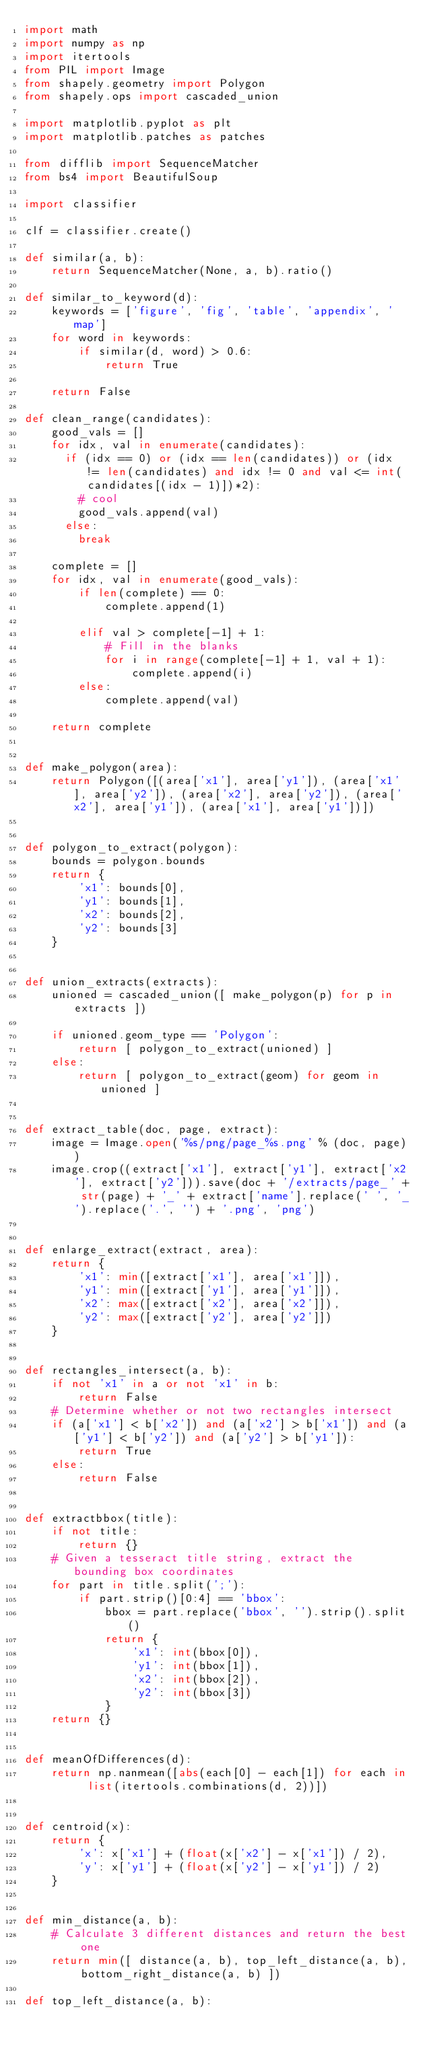<code> <loc_0><loc_0><loc_500><loc_500><_Python_>import math
import numpy as np
import itertools
from PIL import Image
from shapely.geometry import Polygon
from shapely.ops import cascaded_union

import matplotlib.pyplot as plt
import matplotlib.patches as patches

from difflib import SequenceMatcher
from bs4 import BeautifulSoup

import classifier

clf = classifier.create()

def similar(a, b):
    return SequenceMatcher(None, a, b).ratio()

def similar_to_keyword(d):
    keywords = ['figure', 'fig', 'table', 'appendix', 'map']
    for word in keywords:
        if similar(d, word) > 0.6:
            return True

    return False

def clean_range(candidates):
    good_vals = []
    for idx, val in enumerate(candidates):
      if (idx == 0) or (idx == len(candidates)) or (idx != len(candidates) and idx != 0 and val <= int(candidates[(idx - 1)])*2):
        # cool
        good_vals.append(val)
      else:
        break

    complete = []
    for idx, val in enumerate(good_vals):
        if len(complete) == 0:
            complete.append(1)

        elif val > complete[-1] + 1:
            # Fill in the blanks
            for i in range(complete[-1] + 1, val + 1):
                complete.append(i)
        else:
            complete.append(val)

    return complete


def make_polygon(area):
    return Polygon([(area['x1'], area['y1']), (area['x1'], area['y2']), (area['x2'], area['y2']), (area['x2'], area['y1']), (area['x1'], area['y1'])])


def polygon_to_extract(polygon):
    bounds = polygon.bounds
    return {
        'x1': bounds[0],
        'y1': bounds[1],
        'x2': bounds[2],
        'y2': bounds[3]
    }


def union_extracts(extracts):
    unioned = cascaded_union([ make_polygon(p) for p in extracts ])

    if unioned.geom_type == 'Polygon':
        return [ polygon_to_extract(unioned) ]
    else:
        return [ polygon_to_extract(geom) for geom in unioned ]


def extract_table(doc, page, extract):
    image = Image.open('%s/png/page_%s.png' % (doc, page))
    image.crop((extract['x1'], extract['y1'], extract['x2'], extract['y2'])).save(doc + '/extracts/page_' + str(page) + '_' + extract['name'].replace(' ', '_').replace('.', '') + '.png', 'png')


def enlarge_extract(extract, area):
    return {
        'x1': min([extract['x1'], area['x1']]),
        'y1': min([extract['y1'], area['y1']]),
        'x2': max([extract['x2'], area['x2']]),
        'y2': max([extract['y2'], area['y2']])
    }


def rectangles_intersect(a, b):
    if not 'x1' in a or not 'x1' in b:
        return False
    # Determine whether or not two rectangles intersect
    if (a['x1'] < b['x2']) and (a['x2'] > b['x1']) and (a['y1'] < b['y2']) and (a['y2'] > b['y1']):
        return True
    else:
        return False


def extractbbox(title):
    if not title:
        return {}
    # Given a tesseract title string, extract the bounding box coordinates
    for part in title.split(';'):
        if part.strip()[0:4] == 'bbox':
            bbox = part.replace('bbox', '').strip().split()
            return {
                'x1': int(bbox[0]),
                'y1': int(bbox[1]),
                'x2': int(bbox[2]),
                'y2': int(bbox[3])
            }
    return {}


def meanOfDifferences(d):
    return np.nanmean([abs(each[0] - each[1]) for each in  list(itertools.combinations(d, 2))])


def centroid(x):
    return {
        'x': x['x1'] + (float(x['x2'] - x['x1']) / 2),
        'y': x['y1'] + (float(x['y2'] - x['y1']) / 2)
    }


def min_distance(a, b):
    # Calculate 3 different distances and return the best one
    return min([ distance(a, b), top_left_distance(a, b), bottom_right_distance(a, b) ])

def top_left_distance(a, b):</code> 